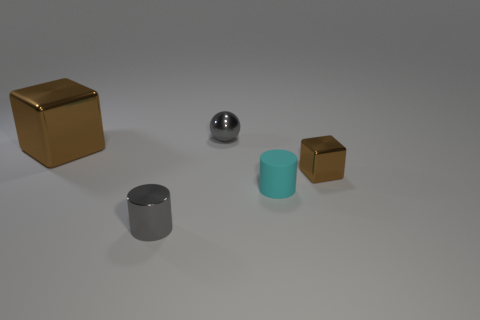What shape is the cyan rubber thing that is the same size as the gray cylinder? The cyan object that is the same size as the gray cylinder is also a cylinder. It's made of a rubber material, which is evident from its matte surface and the way it contrasts with the metallic sheen of the gray cylinder. 